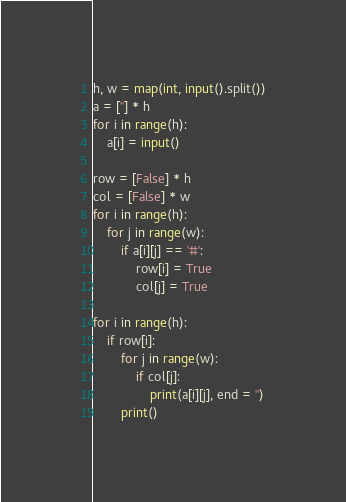<code> <loc_0><loc_0><loc_500><loc_500><_Python_>h, w = map(int, input().split())
a = [''] * h
for i in range(h):
	a[i] = input()

row = [False] * h
col = [False] * w
for i in range(h):
	for j in range(w):
		if a[i][j] == '#':
			row[i] = True
			col[j] = True

for i in range(h):
	if row[i]:
		for j in range(w):
			if col[j]:
				print(a[i][j], end = '')
		print()
</code> 